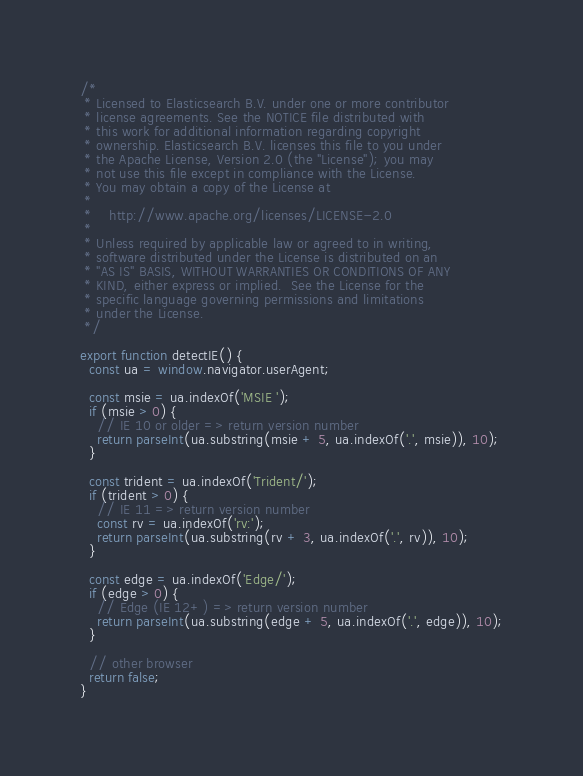<code> <loc_0><loc_0><loc_500><loc_500><_JavaScript_>/*
 * Licensed to Elasticsearch B.V. under one or more contributor
 * license agreements. See the NOTICE file distributed with
 * this work for additional information regarding copyright
 * ownership. Elasticsearch B.V. licenses this file to you under
 * the Apache License, Version 2.0 (the "License"); you may
 * not use this file except in compliance with the License.
 * You may obtain a copy of the License at
 *
 *    http://www.apache.org/licenses/LICENSE-2.0
 *
 * Unless required by applicable law or agreed to in writing,
 * software distributed under the License is distributed on an
 * "AS IS" BASIS, WITHOUT WARRANTIES OR CONDITIONS OF ANY
 * KIND, either express or implied.  See the License for the
 * specific language governing permissions and limitations
 * under the License.
 */

export function detectIE() {
  const ua = window.navigator.userAgent;

  const msie = ua.indexOf('MSIE ');
  if (msie > 0) {
    // IE 10 or older => return version number
    return parseInt(ua.substring(msie + 5, ua.indexOf('.', msie)), 10);
  }

  const trident = ua.indexOf('Trident/');
  if (trident > 0) {
    // IE 11 => return version number
    const rv = ua.indexOf('rv:');
    return parseInt(ua.substring(rv + 3, ua.indexOf('.', rv)), 10);
  }

  const edge = ua.indexOf('Edge/');
  if (edge > 0) {
    // Edge (IE 12+) => return version number
    return parseInt(ua.substring(edge + 5, ua.indexOf('.', edge)), 10);
  }

  // other browser
  return false;
}</code> 